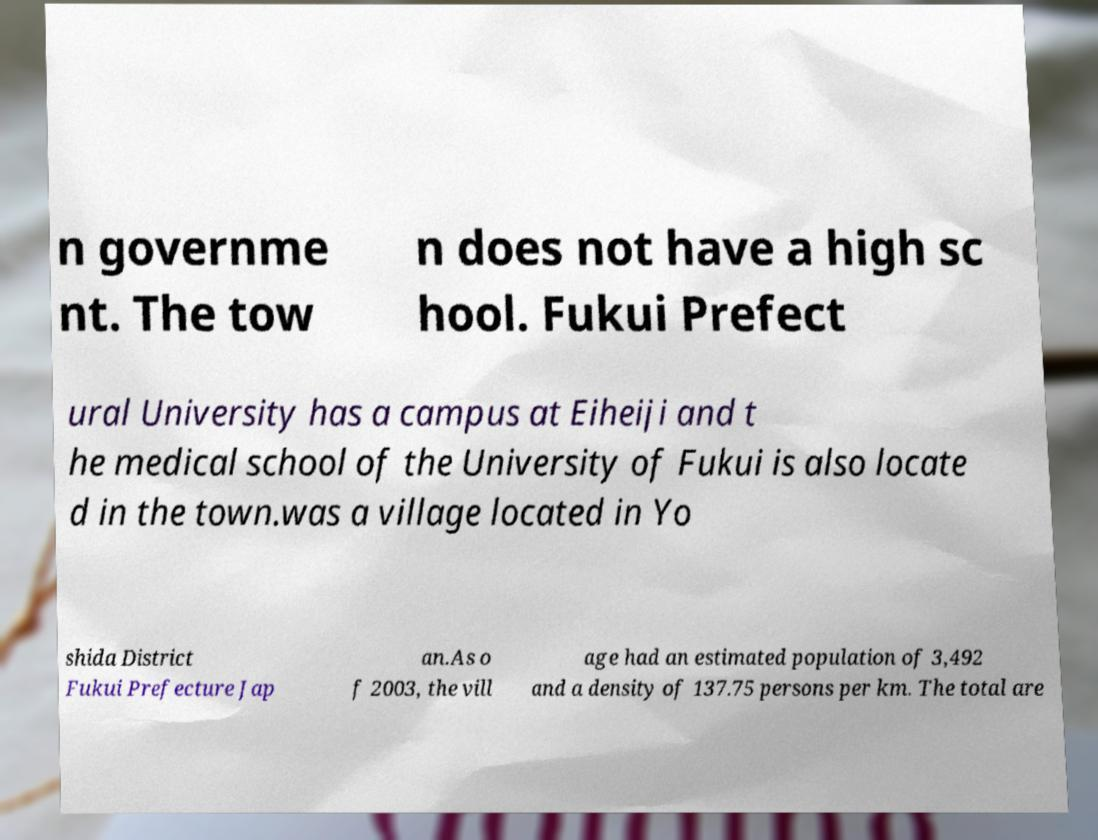I need the written content from this picture converted into text. Can you do that? n governme nt. The tow n does not have a high sc hool. Fukui Prefect ural University has a campus at Eiheiji and t he medical school of the University of Fukui is also locate d in the town.was a village located in Yo shida District Fukui Prefecture Jap an.As o f 2003, the vill age had an estimated population of 3,492 and a density of 137.75 persons per km. The total are 